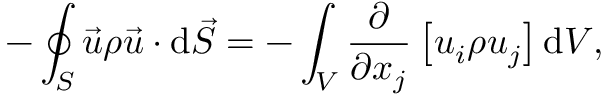Convert formula to latex. <formula><loc_0><loc_0><loc_500><loc_500>- \oint _ { S } { \vec { u } } \rho { \vec { u } } \cdot d { \vec { S } } = - \int _ { V } { \frac { \partial } { \partial x _ { j } } } \left [ u _ { i } \rho u _ { j } \right ] d V ,</formula> 